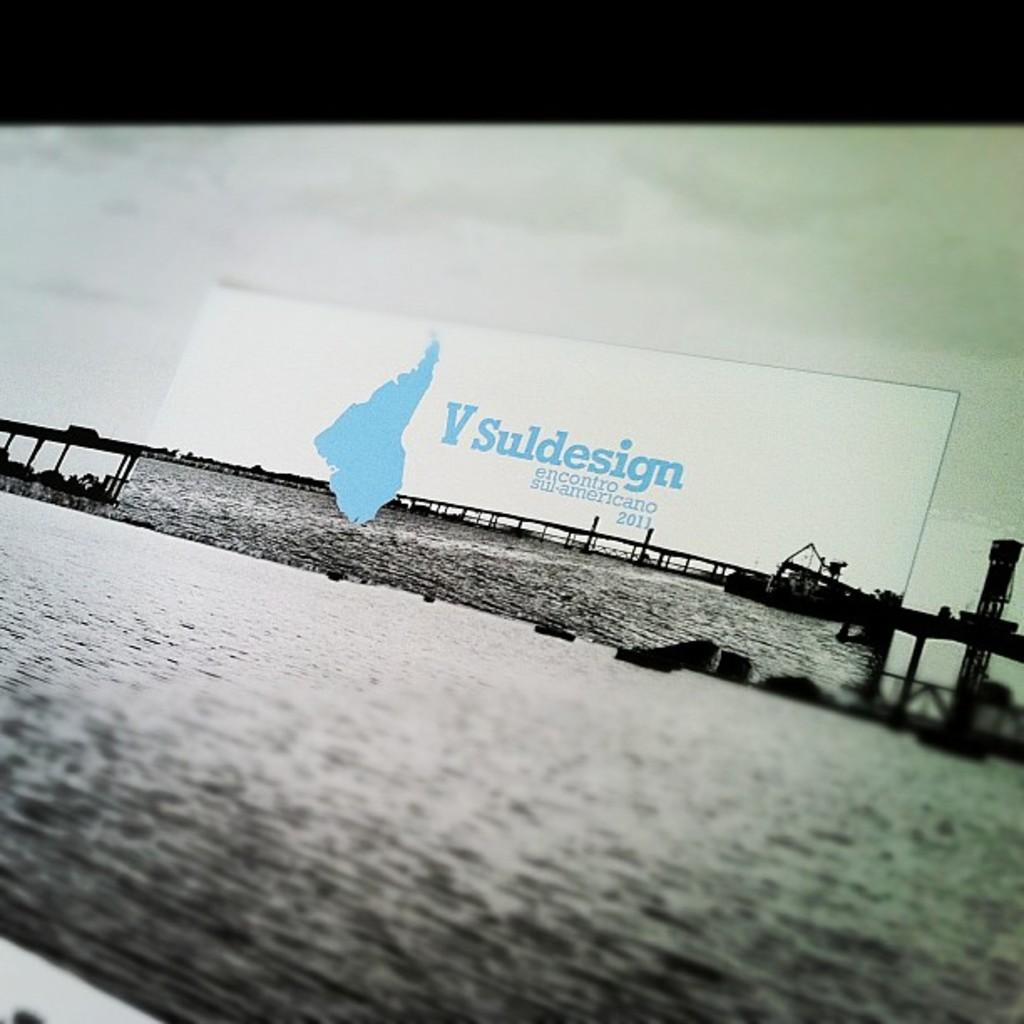<image>
Describe the image concisely. A billboard sign with the name V Suldesign near the bridge over the water. 